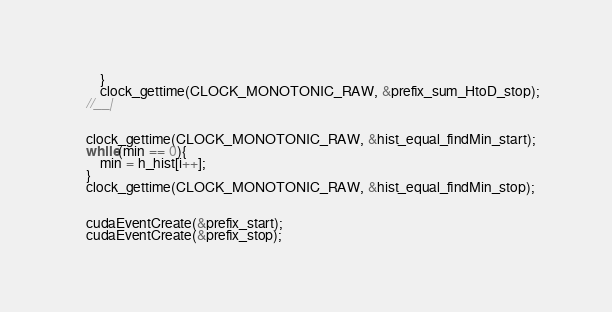<code> <loc_0><loc_0><loc_500><loc_500><_Cuda_>		}
		clock_gettime(CLOCK_MONOTONIC_RAW, &prefix_sum_HtoD_stop);
	//__|


	clock_gettime(CLOCK_MONOTONIC_RAW, &hist_equal_findMin_start);
	while(min == 0){
        min = h_hist[i++];
	}
	clock_gettime(CLOCK_MONOTONIC_RAW, &hist_equal_findMin_stop);

	
	cudaEventCreate(&prefix_start);
	cudaEventCreate(&prefix_stop);
</code> 